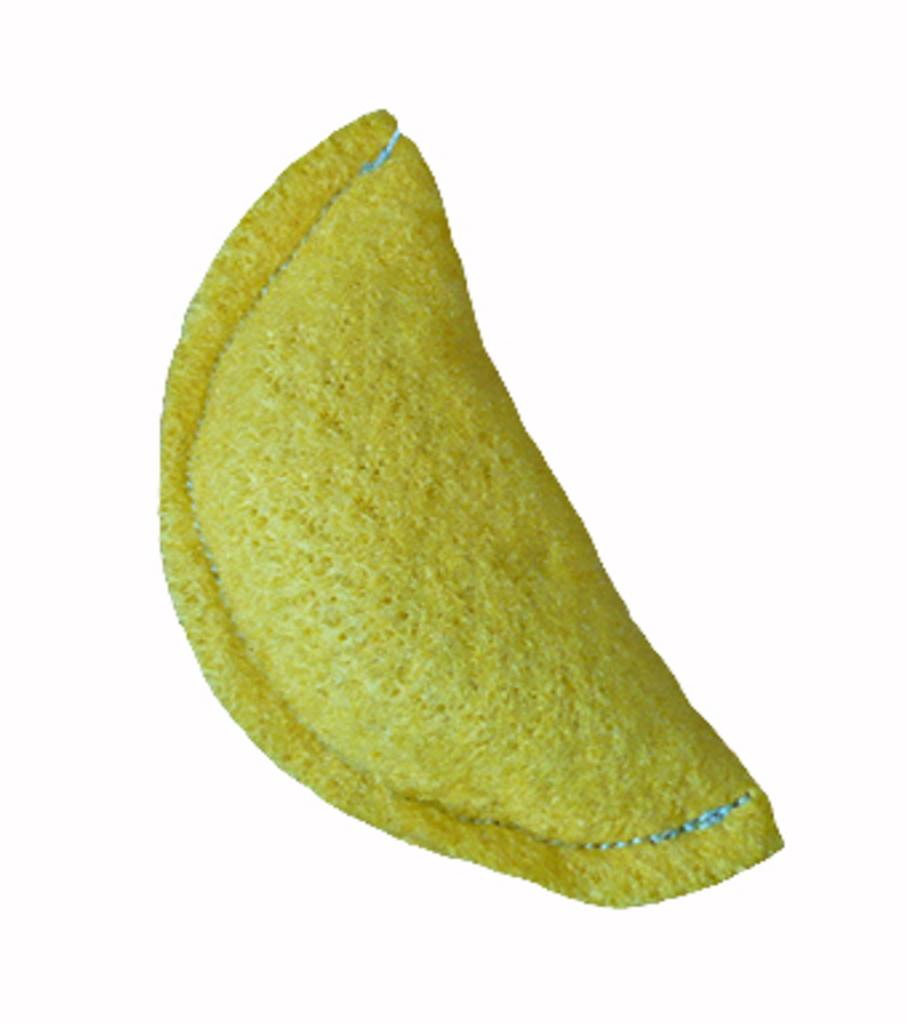What is the main subject in the center of the image? There is an object in the center of the image. What color is the object in the image? The object is yellow in color. What type of gold object can be seen in the image? There is no gold object present in the image; the object is described as yellow in color. What shape is the cannon in the image? There is no cannon present in the image. 